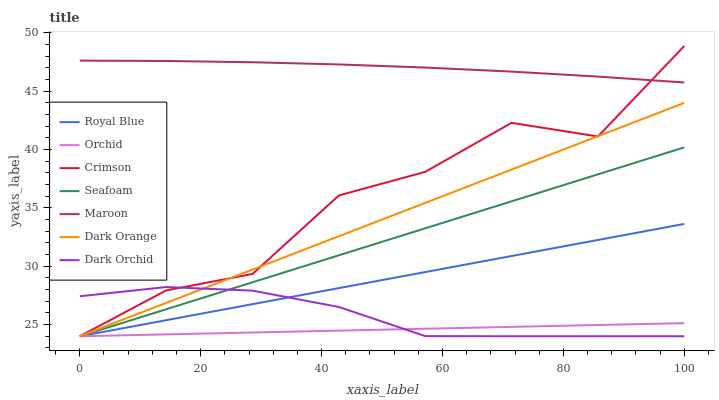Does Orchid have the minimum area under the curve?
Answer yes or no. Yes. Does Maroon have the maximum area under the curve?
Answer yes or no. Yes. Does Seafoam have the minimum area under the curve?
Answer yes or no. No. Does Seafoam have the maximum area under the curve?
Answer yes or no. No. Is Orchid the smoothest?
Answer yes or no. Yes. Is Crimson the roughest?
Answer yes or no. Yes. Is Seafoam the smoothest?
Answer yes or no. No. Is Seafoam the roughest?
Answer yes or no. No. Does Maroon have the lowest value?
Answer yes or no. No. Does Seafoam have the highest value?
Answer yes or no. No. Is Dark Orange less than Maroon?
Answer yes or no. Yes. Is Maroon greater than Dark Orange?
Answer yes or no. Yes. Does Dark Orange intersect Maroon?
Answer yes or no. No. 